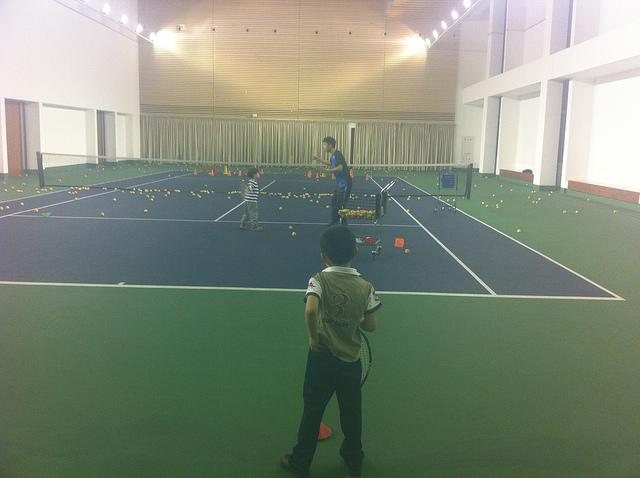Is this a busy place?
Quick response, please. No. What are the yellow objects on the ground?
Give a very brief answer. Balls. Is this ping pong?
Give a very brief answer. No. Should she wear sunblock?
Quick response, please. No. How many players are on the field?
Keep it brief. 3. Is this a match of the ATP World Tour?
Be succinct. No. Are there two people here?
Short answer required. Yes. 